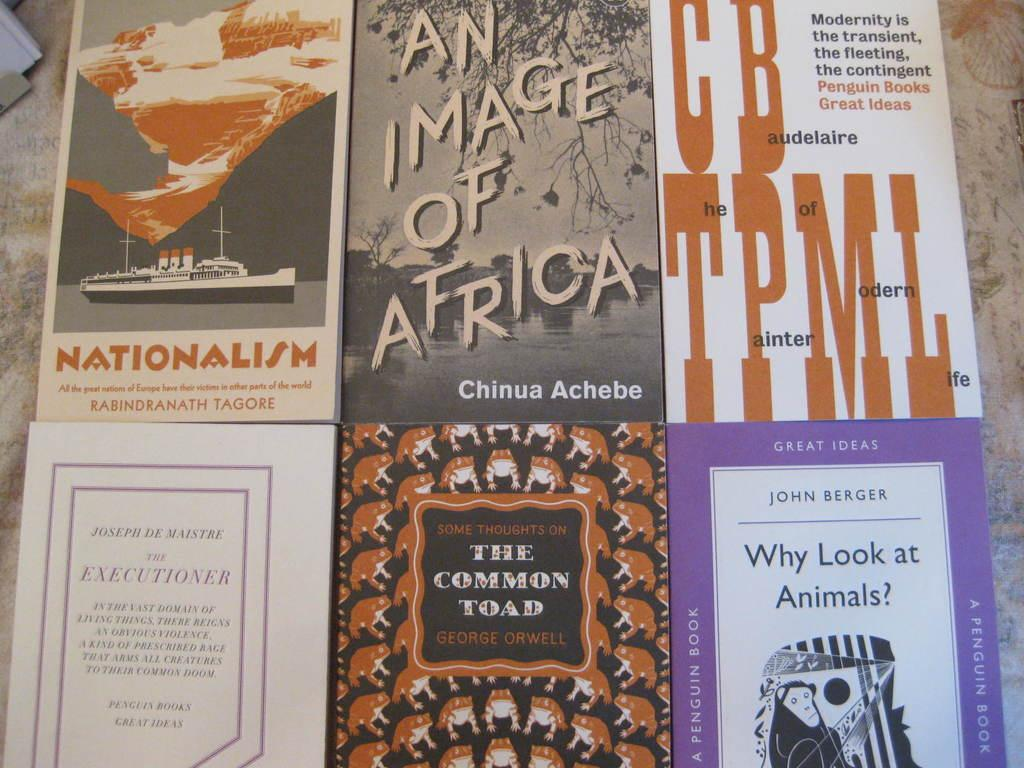Provide a one-sentence caption for the provided image. The common Toad book is on the bottom in the middle by George Orwell. 